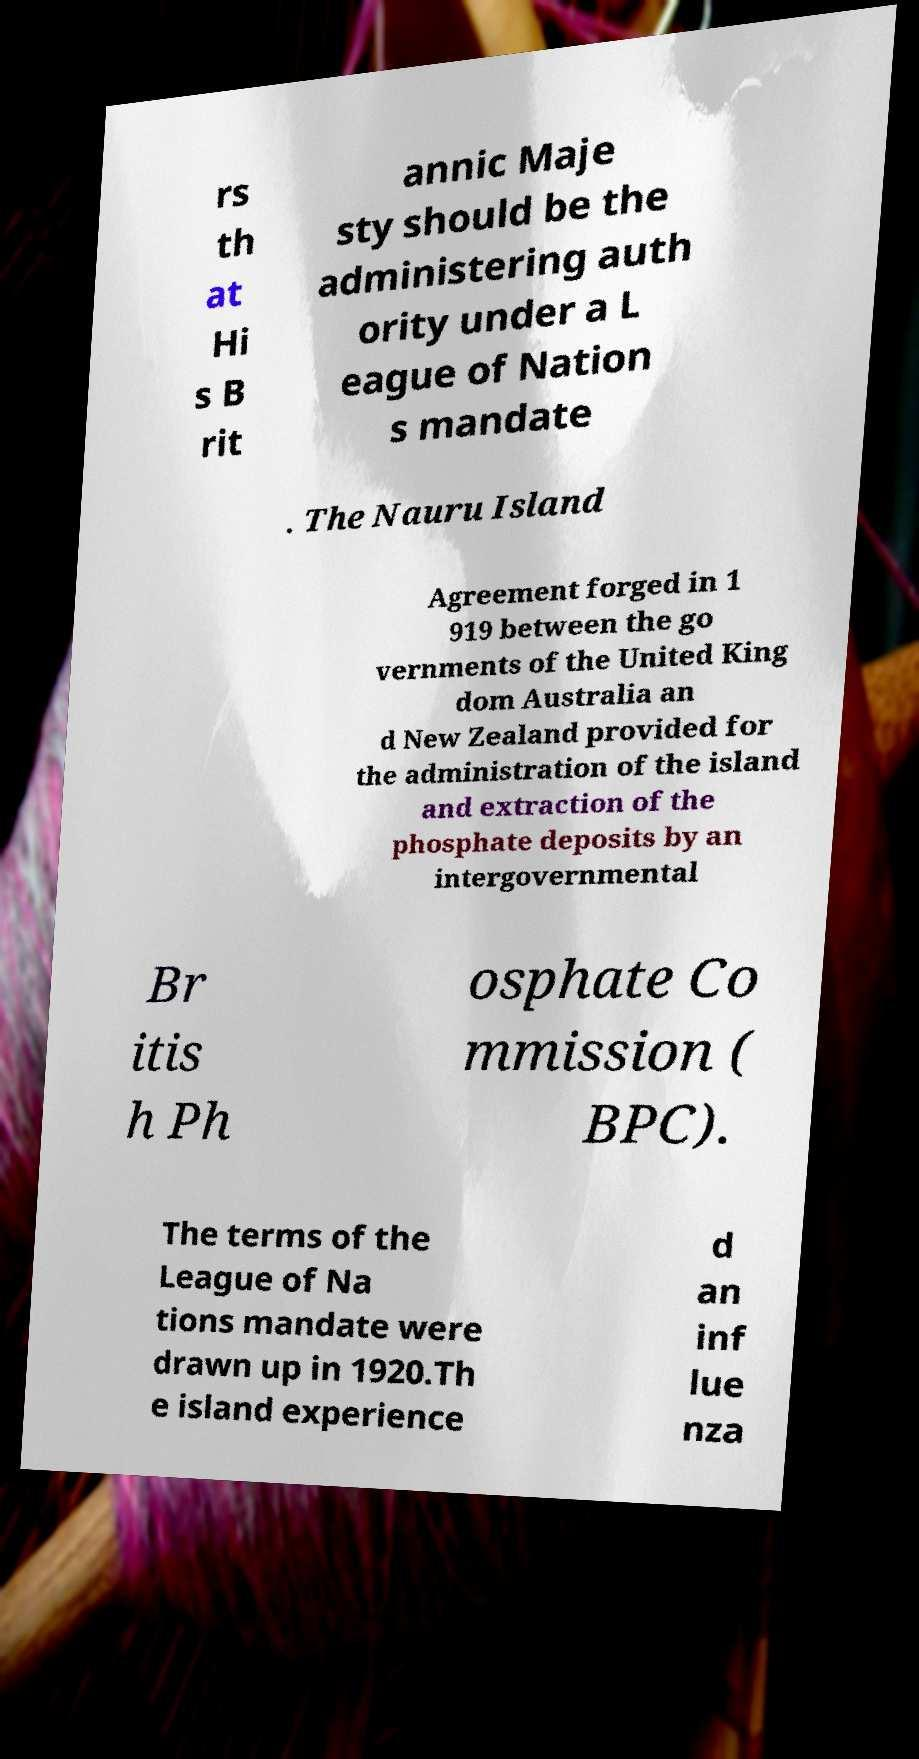There's text embedded in this image that I need extracted. Can you transcribe it verbatim? rs th at Hi s B rit annic Maje sty should be the administering auth ority under a L eague of Nation s mandate . The Nauru Island Agreement forged in 1 919 between the go vernments of the United King dom Australia an d New Zealand provided for the administration of the island and extraction of the phosphate deposits by an intergovernmental Br itis h Ph osphate Co mmission ( BPC). The terms of the League of Na tions mandate were drawn up in 1920.Th e island experience d an inf lue nza 